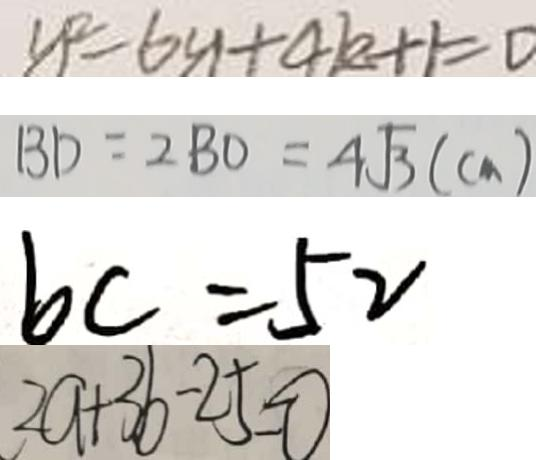<formula> <loc_0><loc_0><loc_500><loc_500>y ^ { 2 } = 6 y + 4 k + 1 = 0 
 B D = 2 B O = 4 \sqrt { 3 } ( c m ) 
 b c = 5 2 
 2 a + 3 b - 2 5 = 0</formula> 